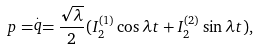<formula> <loc_0><loc_0><loc_500><loc_500>p = \stackrel { . } { q } = \frac { \sqrt { \lambda } } { 2 } ( I _ { 2 } ^ { ( 1 ) } \cos \lambda t + I _ { 2 } ^ { ( 2 ) } \sin \lambda t ) ,</formula> 